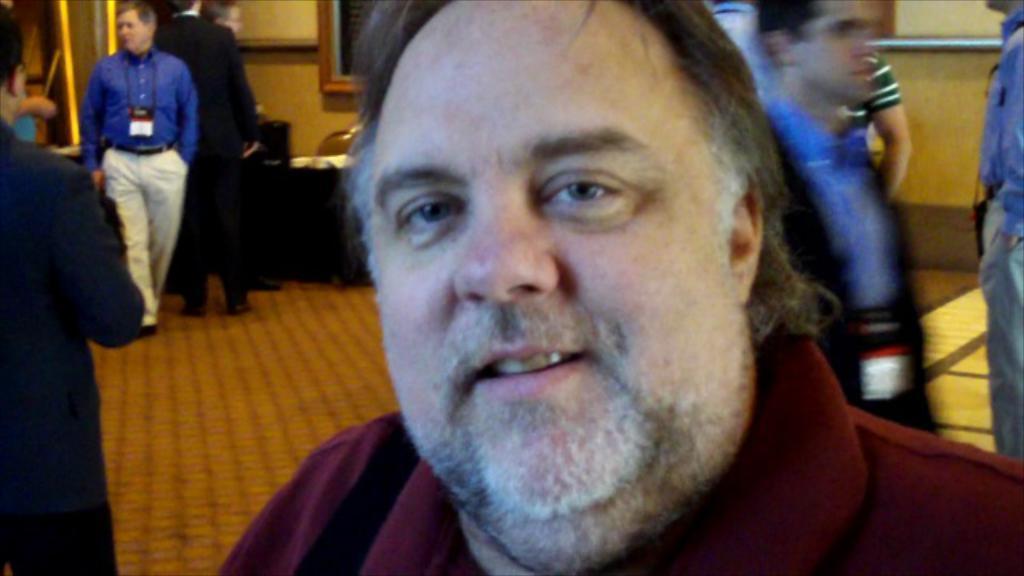How would you summarize this image in a sentence or two? In this picture we can see the man standing in the front wearing a red t-shirt, smiling and giving a pose to the camera. Behind we can see some people standing in the hall. In the background there is a wall and photo frame. 